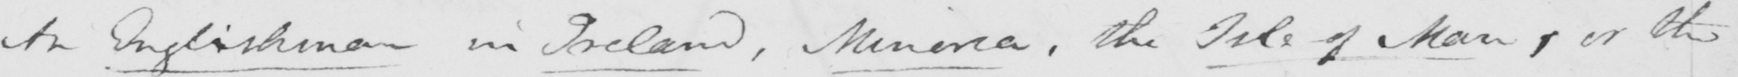Can you tell me what this handwritten text says? An Englishman in Ireland , Minorca , the Isle of Man , or the 